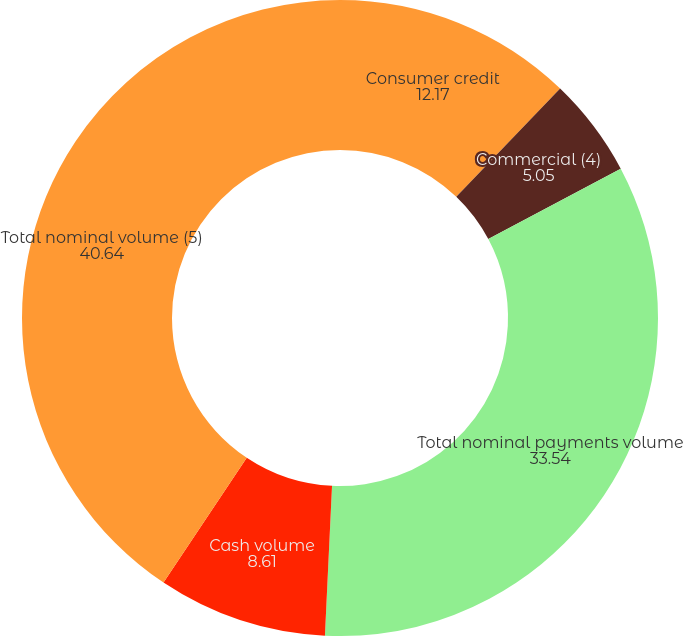Convert chart to OTSL. <chart><loc_0><loc_0><loc_500><loc_500><pie_chart><fcel>Consumer credit<fcel>Commercial (4)<fcel>Total nominal payments volume<fcel>Cash volume<fcel>Total nominal volume (5)<nl><fcel>12.17%<fcel>5.05%<fcel>33.54%<fcel>8.61%<fcel>40.64%<nl></chart> 